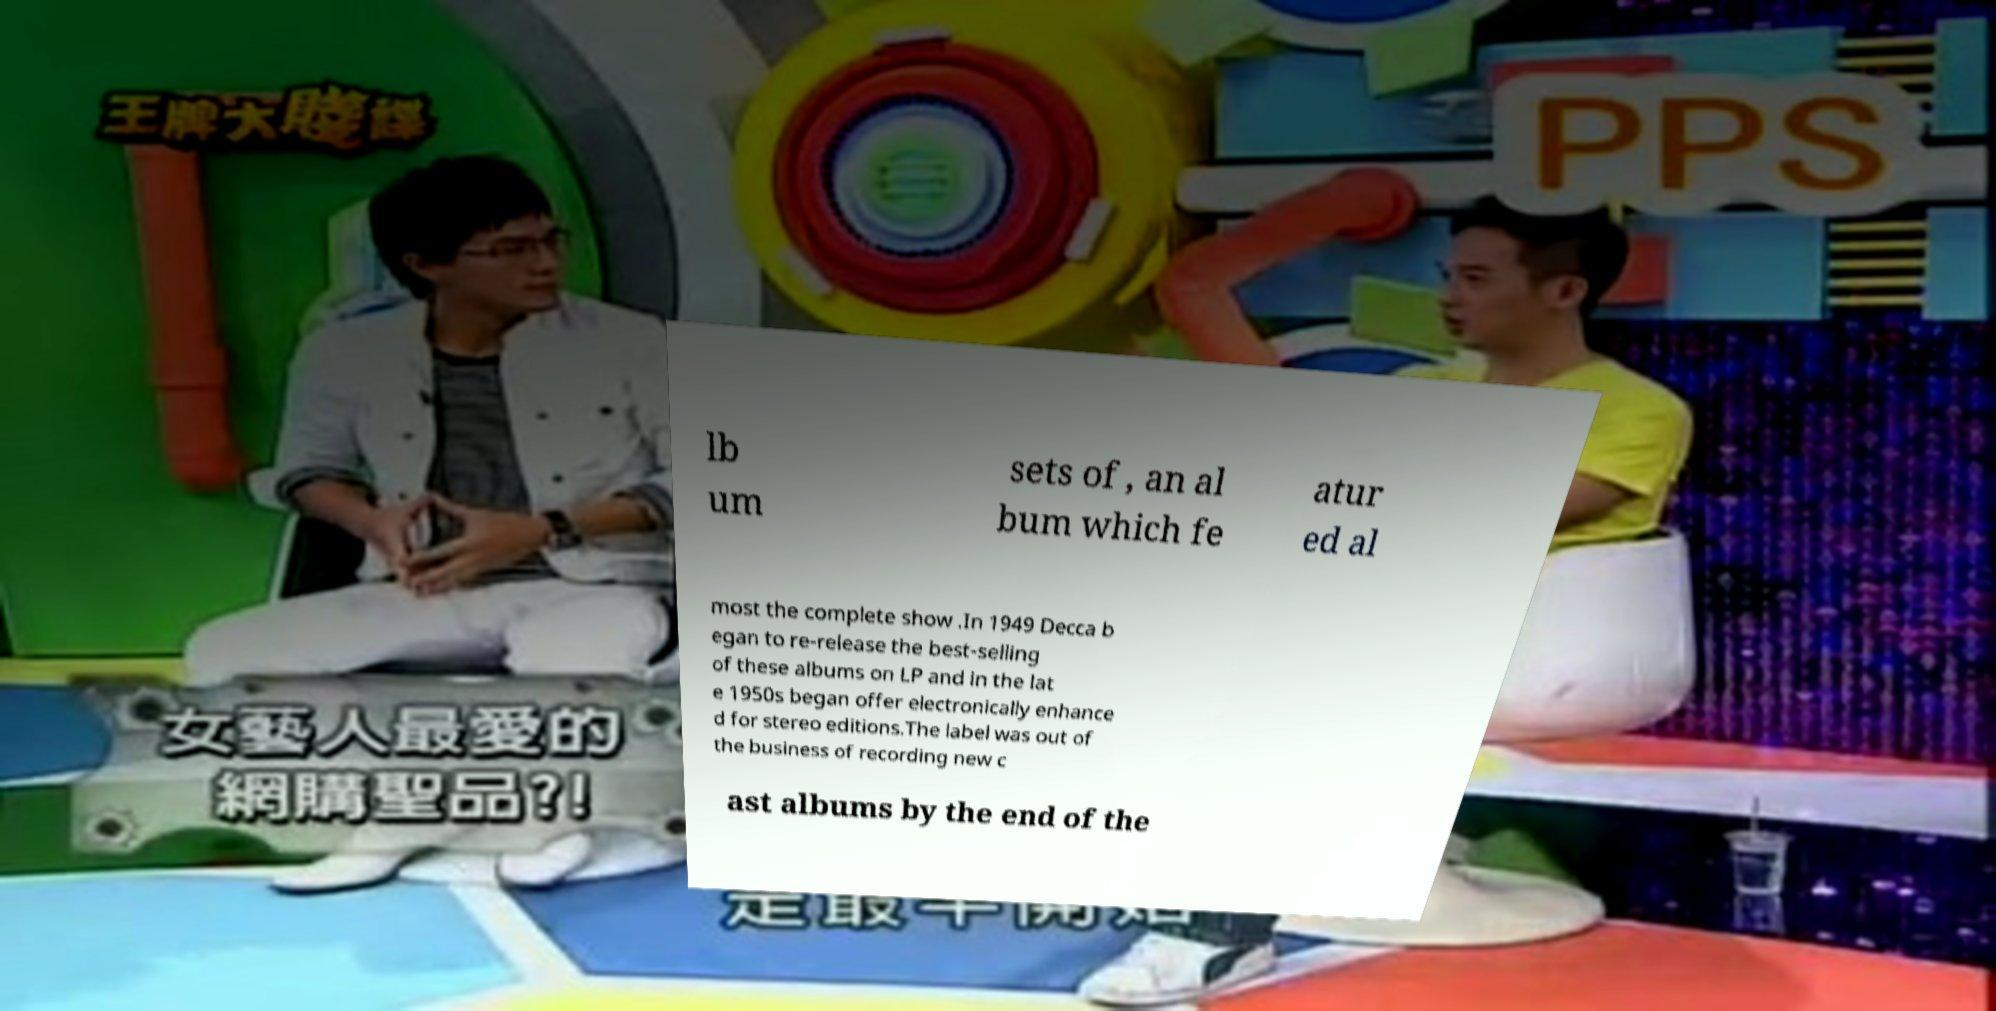Can you read and provide the text displayed in the image?This photo seems to have some interesting text. Can you extract and type it out for me? lb um sets of , an al bum which fe atur ed al most the complete show .In 1949 Decca b egan to re-release the best-selling of these albums on LP and in the lat e 1950s began offer electronically enhance d for stereo editions.The label was out of the business of recording new c ast albums by the end of the 